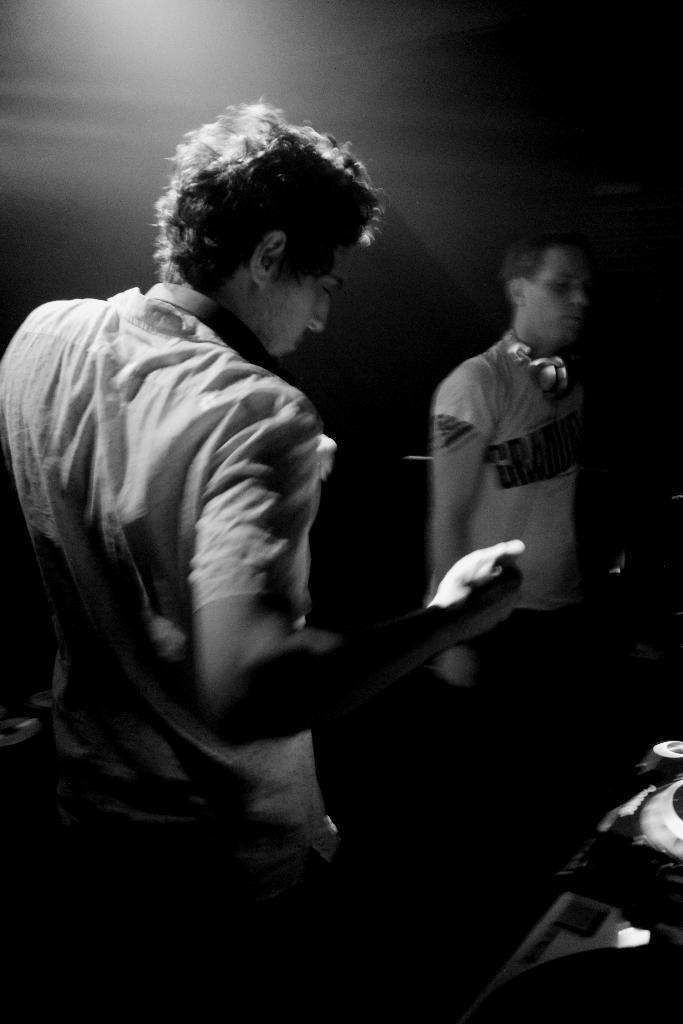How many people are in the image? There are two men standing in the image. What can be seen on the right side of the image? There are objects on the right side of the image. What is the color scheme of the image? The image is black and white in color. What type of jam is being spread on the sofa in the image? There is no jam or sofa present in the image; it features two men standing in a black and white setting. 